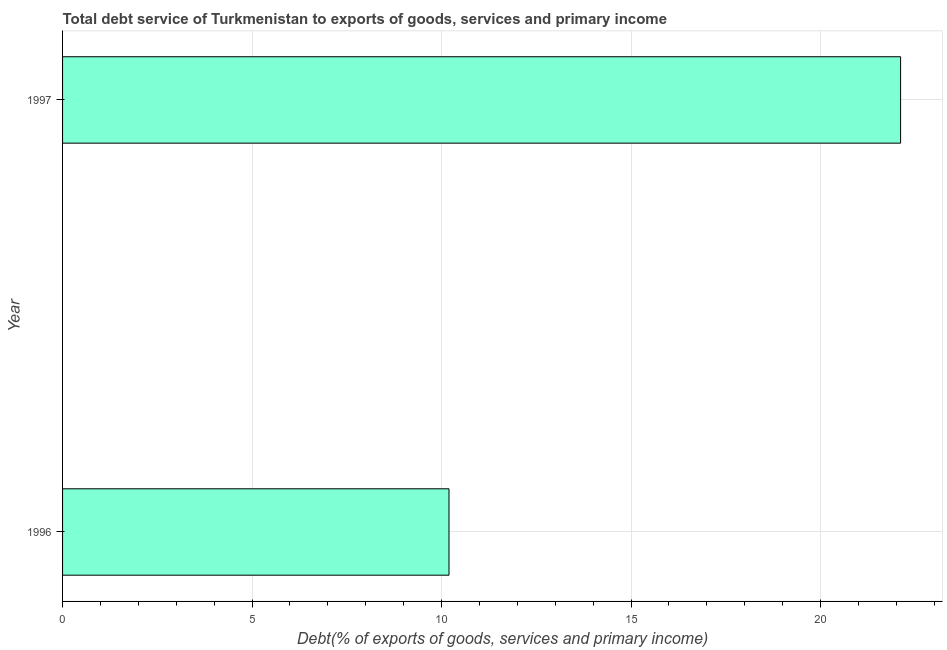Does the graph contain grids?
Offer a very short reply. Yes. What is the title of the graph?
Offer a terse response. Total debt service of Turkmenistan to exports of goods, services and primary income. What is the label or title of the X-axis?
Offer a very short reply. Debt(% of exports of goods, services and primary income). What is the total debt service in 1996?
Give a very brief answer. 10.2. Across all years, what is the maximum total debt service?
Offer a very short reply. 22.11. Across all years, what is the minimum total debt service?
Keep it short and to the point. 10.2. What is the sum of the total debt service?
Make the answer very short. 32.31. What is the difference between the total debt service in 1996 and 1997?
Provide a short and direct response. -11.92. What is the average total debt service per year?
Offer a terse response. 16.15. What is the median total debt service?
Your answer should be very brief. 16.15. Do a majority of the years between 1997 and 1996 (inclusive) have total debt service greater than 11 %?
Provide a short and direct response. No. What is the ratio of the total debt service in 1996 to that in 1997?
Your response must be concise. 0.46. Is the total debt service in 1996 less than that in 1997?
Offer a terse response. Yes. What is the difference between two consecutive major ticks on the X-axis?
Provide a succinct answer. 5. Are the values on the major ticks of X-axis written in scientific E-notation?
Provide a short and direct response. No. What is the Debt(% of exports of goods, services and primary income) of 1996?
Keep it short and to the point. 10.2. What is the Debt(% of exports of goods, services and primary income) in 1997?
Ensure brevity in your answer.  22.11. What is the difference between the Debt(% of exports of goods, services and primary income) in 1996 and 1997?
Your answer should be very brief. -11.92. What is the ratio of the Debt(% of exports of goods, services and primary income) in 1996 to that in 1997?
Offer a terse response. 0.46. 